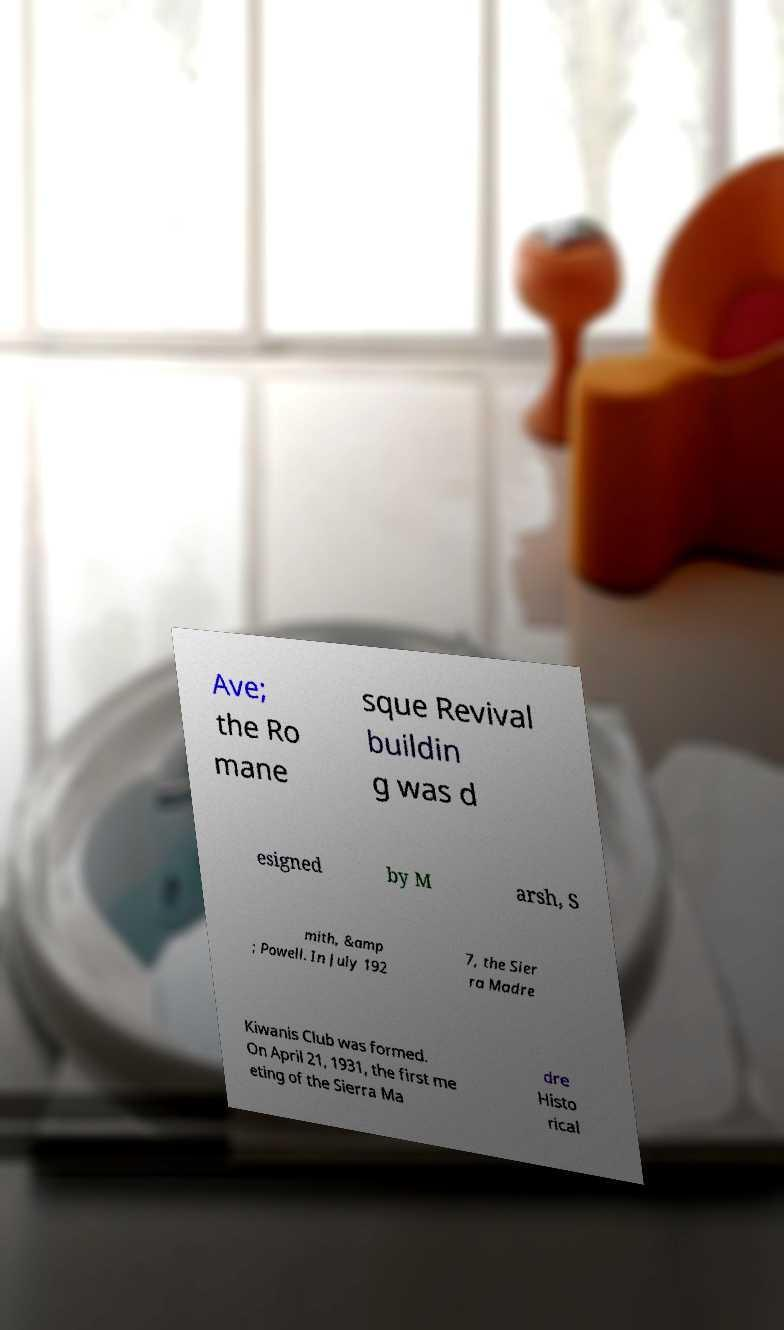What messages or text are displayed in this image? I need them in a readable, typed format. Ave; the Ro mane sque Revival buildin g was d esigned by M arsh, S mith, &amp ; Powell. In July 192 7, the Sier ra Madre Kiwanis Club was formed. On April 21, 1931, the first me eting of the Sierra Ma dre Histo rical 